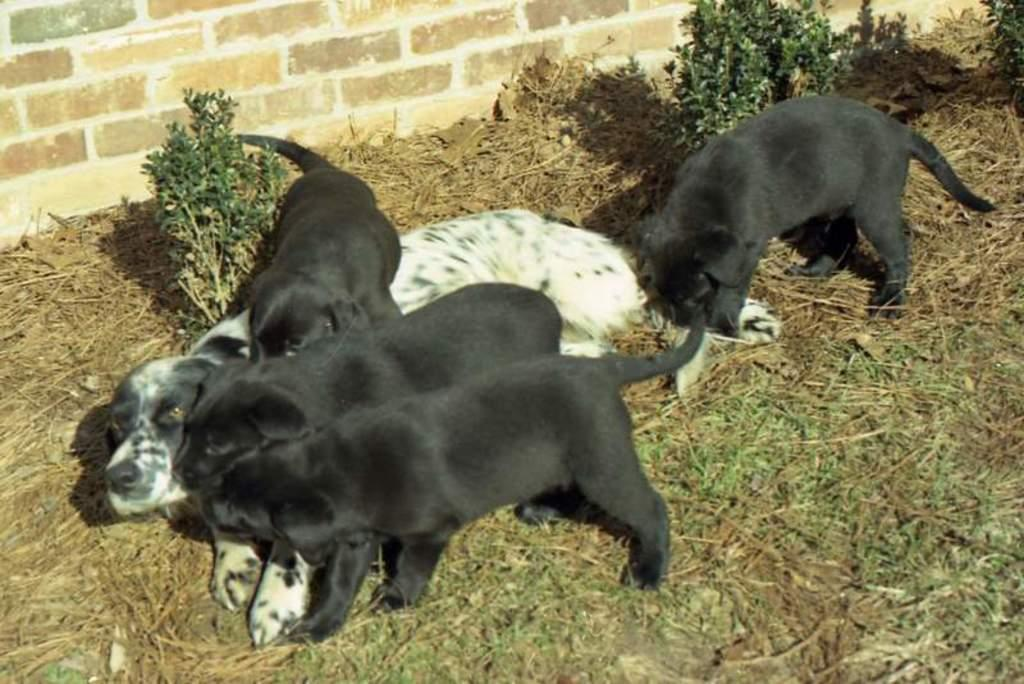What type of animal is present in the image? There is a dog in the image. Are there any other animals in the image? Yes, there are puppies in the image. Where are the dog and puppies located? The dog and puppies are on the ground. What type of street is visible in the image? There is no street present in the image; it features a dog and puppies on the ground. How many friends can be seen interacting with the dog in the image? There are no friends visible in the image; it only features a dog and puppies. 